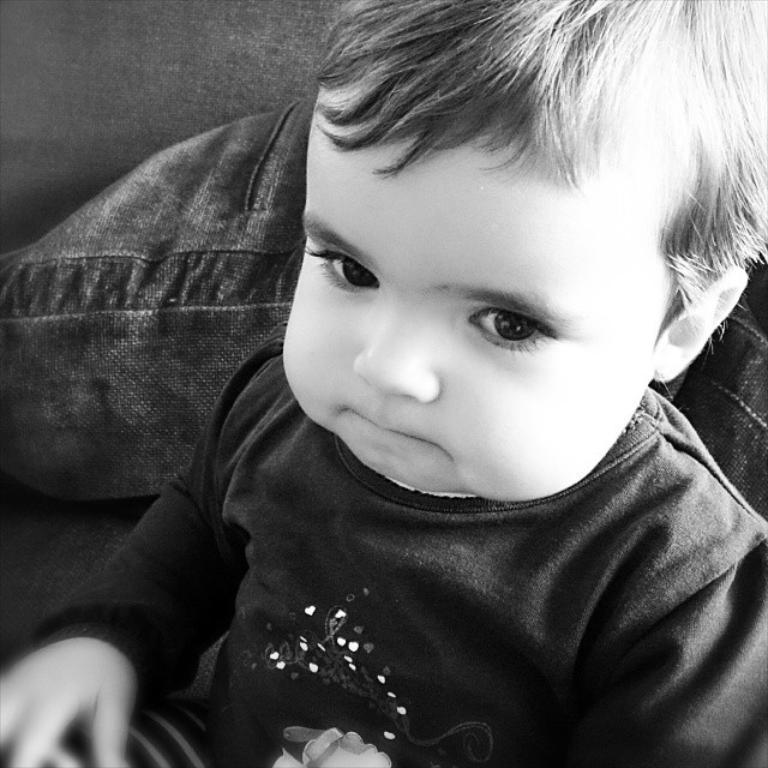Can you describe this image briefly? In the middle of the image we can see a boy, he is seated, and it is a black and white photography. 